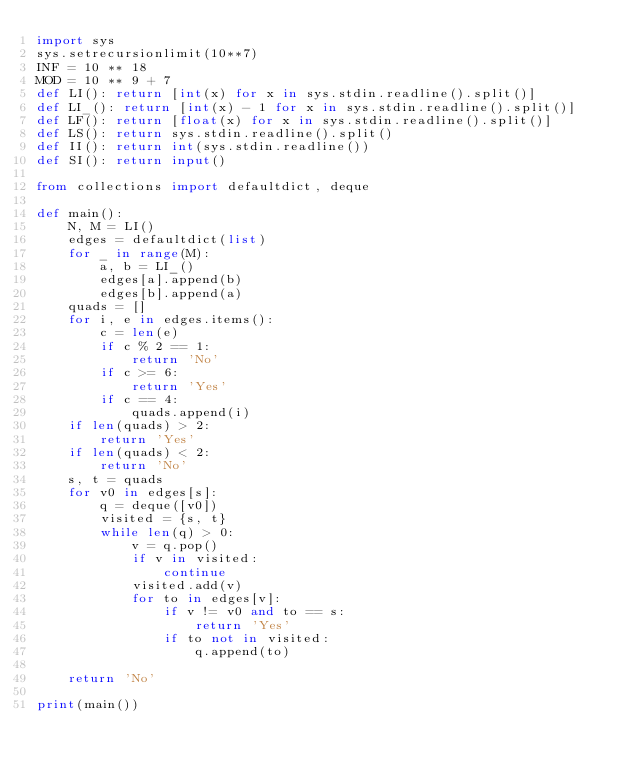<code> <loc_0><loc_0><loc_500><loc_500><_Python_>import sys
sys.setrecursionlimit(10**7)
INF = 10 ** 18
MOD = 10 ** 9 + 7
def LI(): return [int(x) for x in sys.stdin.readline().split()]
def LI_(): return [int(x) - 1 for x in sys.stdin.readline().split()]
def LF(): return [float(x) for x in sys.stdin.readline().split()]
def LS(): return sys.stdin.readline().split()
def II(): return int(sys.stdin.readline())
def SI(): return input()

from collections import defaultdict, deque

def main():
    N, M = LI()
    edges = defaultdict(list)
    for _ in range(M):
        a, b = LI_()
        edges[a].append(b)
        edges[b].append(a)
    quads = []
    for i, e in edges.items():
        c = len(e)
        if c % 2 == 1:
            return 'No'
        if c >= 6:
            return 'Yes'
        if c == 4:
            quads.append(i)
    if len(quads) > 2:
        return 'Yes'
    if len(quads) < 2:
        return 'No'
    s, t = quads
    for v0 in edges[s]:
        q = deque([v0])
        visited = {s, t}
        while len(q) > 0:
            v = q.pop()
            if v in visited:
                continue
            visited.add(v)
            for to in edges[v]:
                if v != v0 and to == s:
                    return 'Yes'
                if to not in visited:
                    q.append(to)

    return 'No'

print(main())</code> 